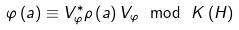<formula> <loc_0><loc_0><loc_500><loc_500>\varphi \left ( a \right ) \equiv V _ { \varphi } ^ { \ast } \rho \left ( a \right ) V _ { \varphi } \ \mathrm { m o d } \ K \left ( H \right )</formula> 